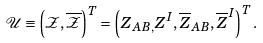<formula> <loc_0><loc_0><loc_500><loc_500>\mathcal { U } \equiv \left ( \mathcal { Z } , \overline { \mathcal { Z } } \right ) ^ { T } = \left ( Z _ { A B , } Z ^ { I } , \overline { Z } _ { A B } , \overline { Z } ^ { I } \right ) ^ { T } .</formula> 